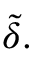Convert formula to latex. <formula><loc_0><loc_0><loc_500><loc_500>{ \tilde { \delta } } .</formula> 